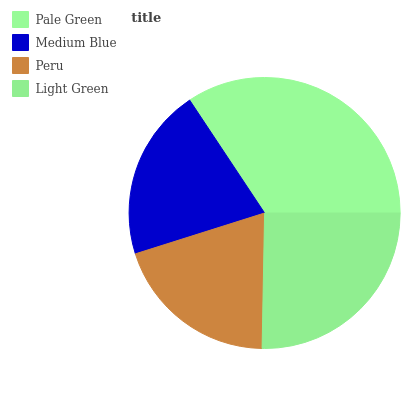Is Peru the minimum?
Answer yes or no. Yes. Is Pale Green the maximum?
Answer yes or no. Yes. Is Medium Blue the minimum?
Answer yes or no. No. Is Medium Blue the maximum?
Answer yes or no. No. Is Pale Green greater than Medium Blue?
Answer yes or no. Yes. Is Medium Blue less than Pale Green?
Answer yes or no. Yes. Is Medium Blue greater than Pale Green?
Answer yes or no. No. Is Pale Green less than Medium Blue?
Answer yes or no. No. Is Light Green the high median?
Answer yes or no. Yes. Is Medium Blue the low median?
Answer yes or no. Yes. Is Medium Blue the high median?
Answer yes or no. No. Is Pale Green the low median?
Answer yes or no. No. 